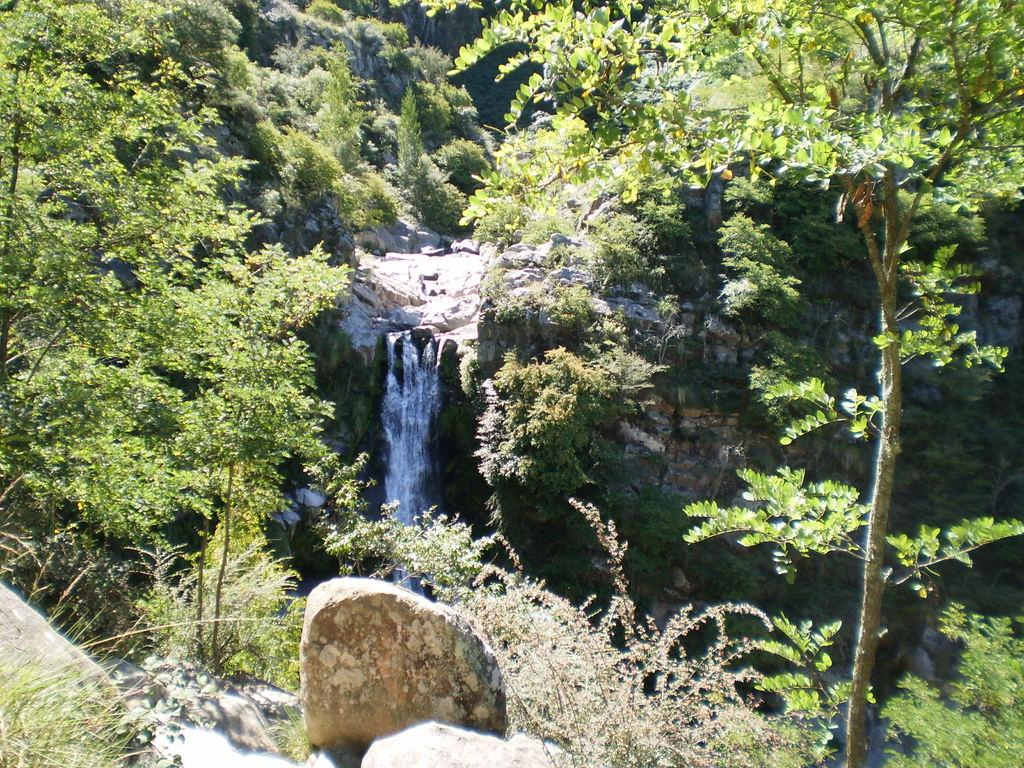What type of vegetation can be seen in the image? There are trees in the image. What natural element is visible in the image? There is water visible in the image. What type of pet can be seen playing with a pail in the image? There is no pet or pail present in the image; it only features trees and water. What does the image convey about peace in the world? The image does not convey any information about peace in the world, as it only shows trees and water. 